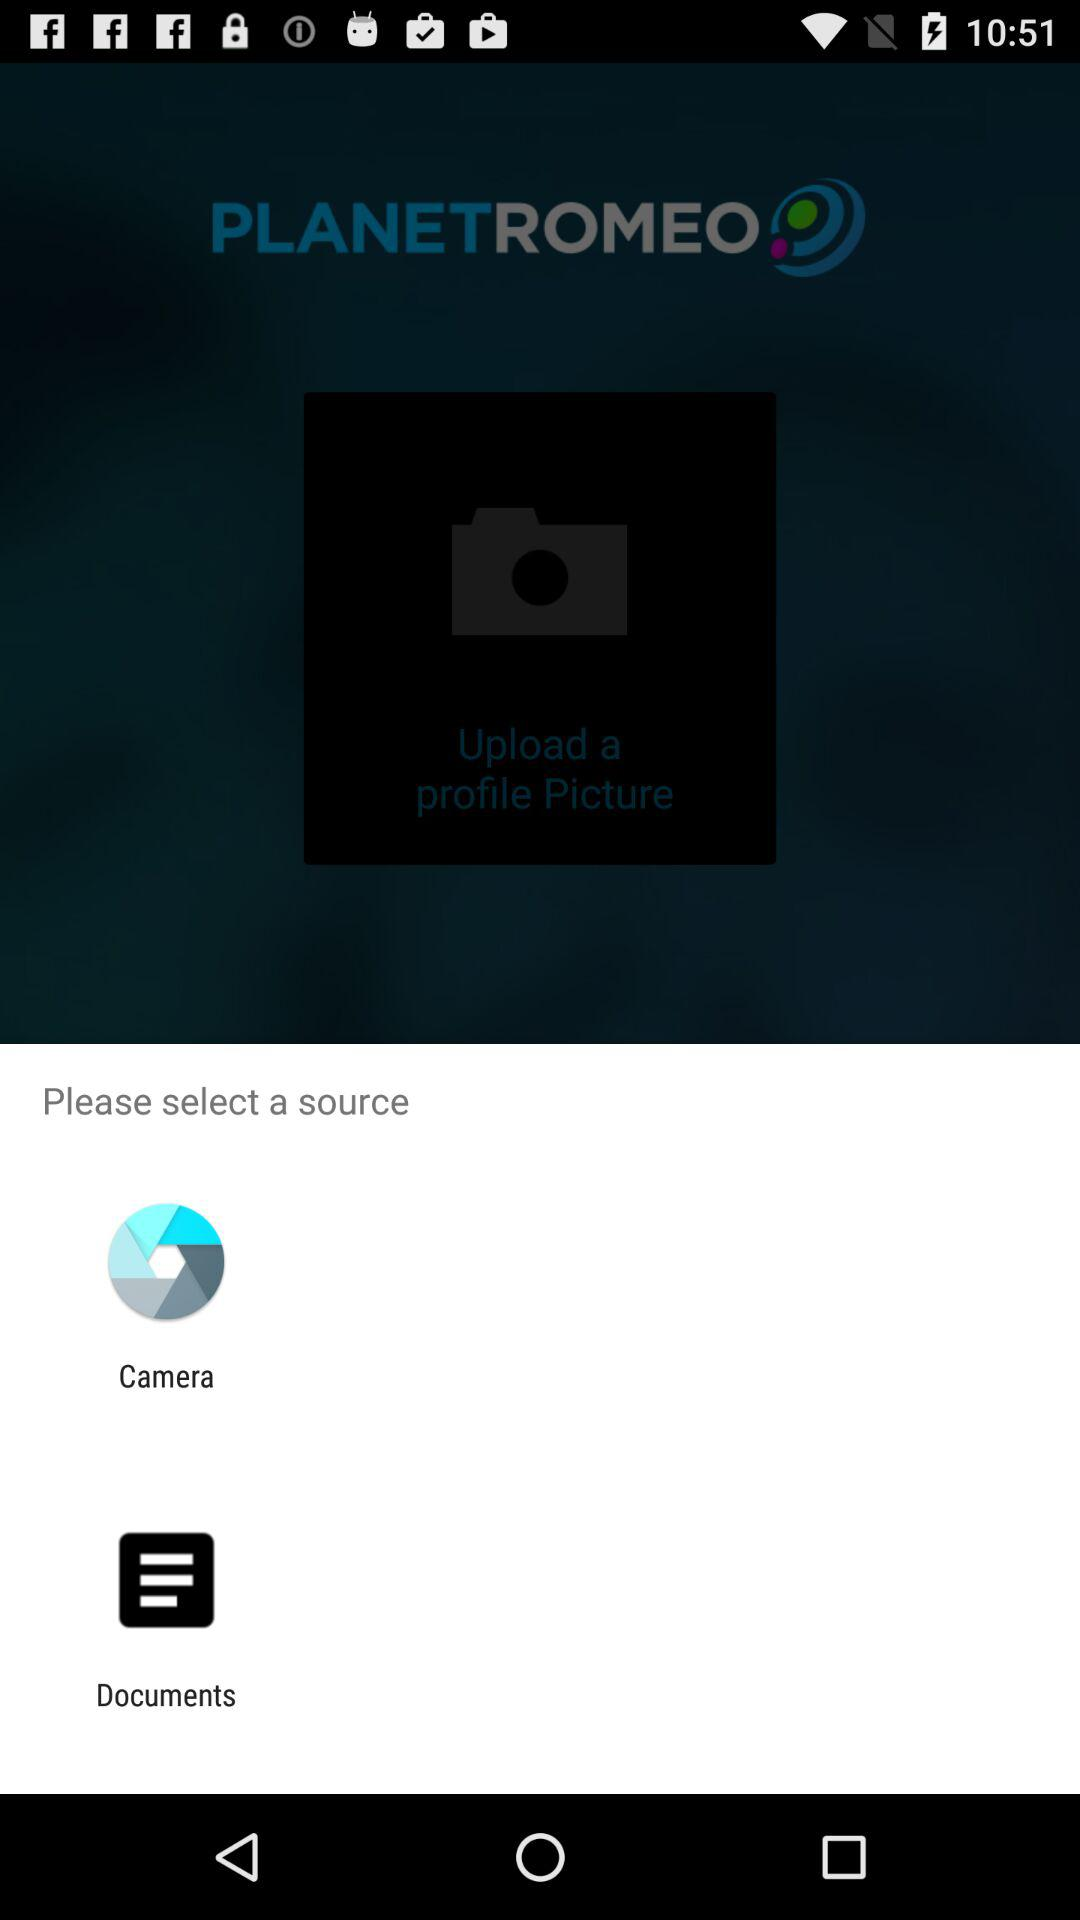What are the sources that can be selected? The sources are "Camera" and "Documents". 